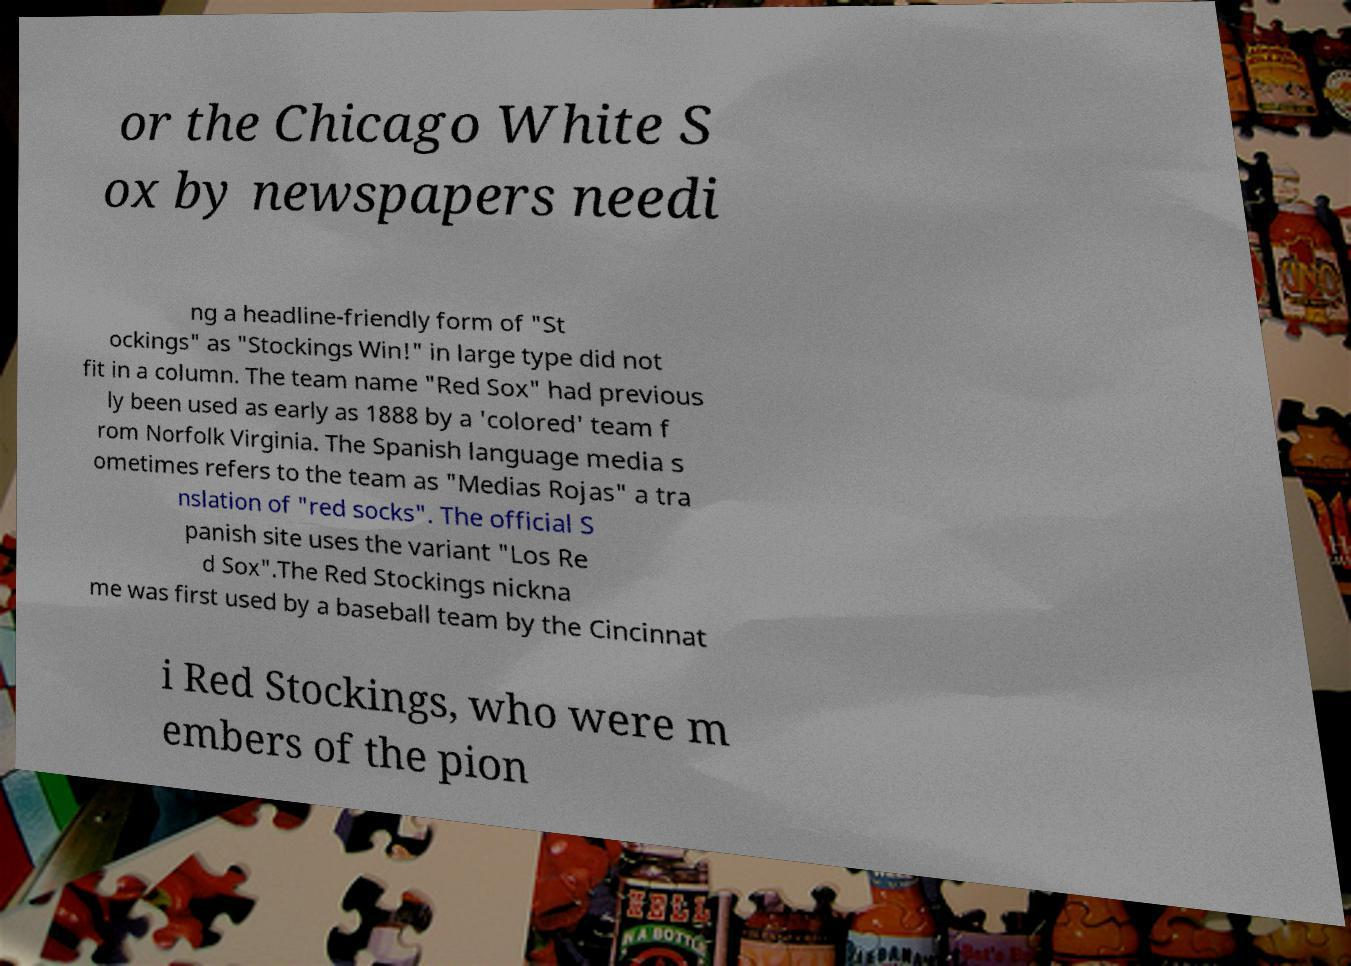Could you extract and type out the text from this image? or the Chicago White S ox by newspapers needi ng a headline-friendly form of "St ockings" as "Stockings Win!" in large type did not fit in a column. The team name "Red Sox" had previous ly been used as early as 1888 by a 'colored' team f rom Norfolk Virginia. The Spanish language media s ometimes refers to the team as "Medias Rojas" a tra nslation of "red socks". The official S panish site uses the variant "Los Re d Sox".The Red Stockings nickna me was first used by a baseball team by the Cincinnat i Red Stockings, who were m embers of the pion 